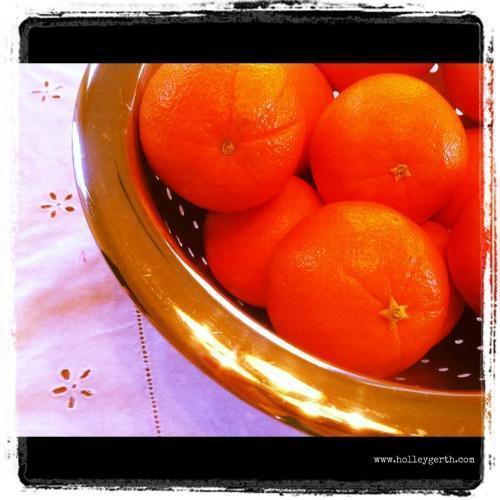How many oranges are there?
Give a very brief answer. 8. 